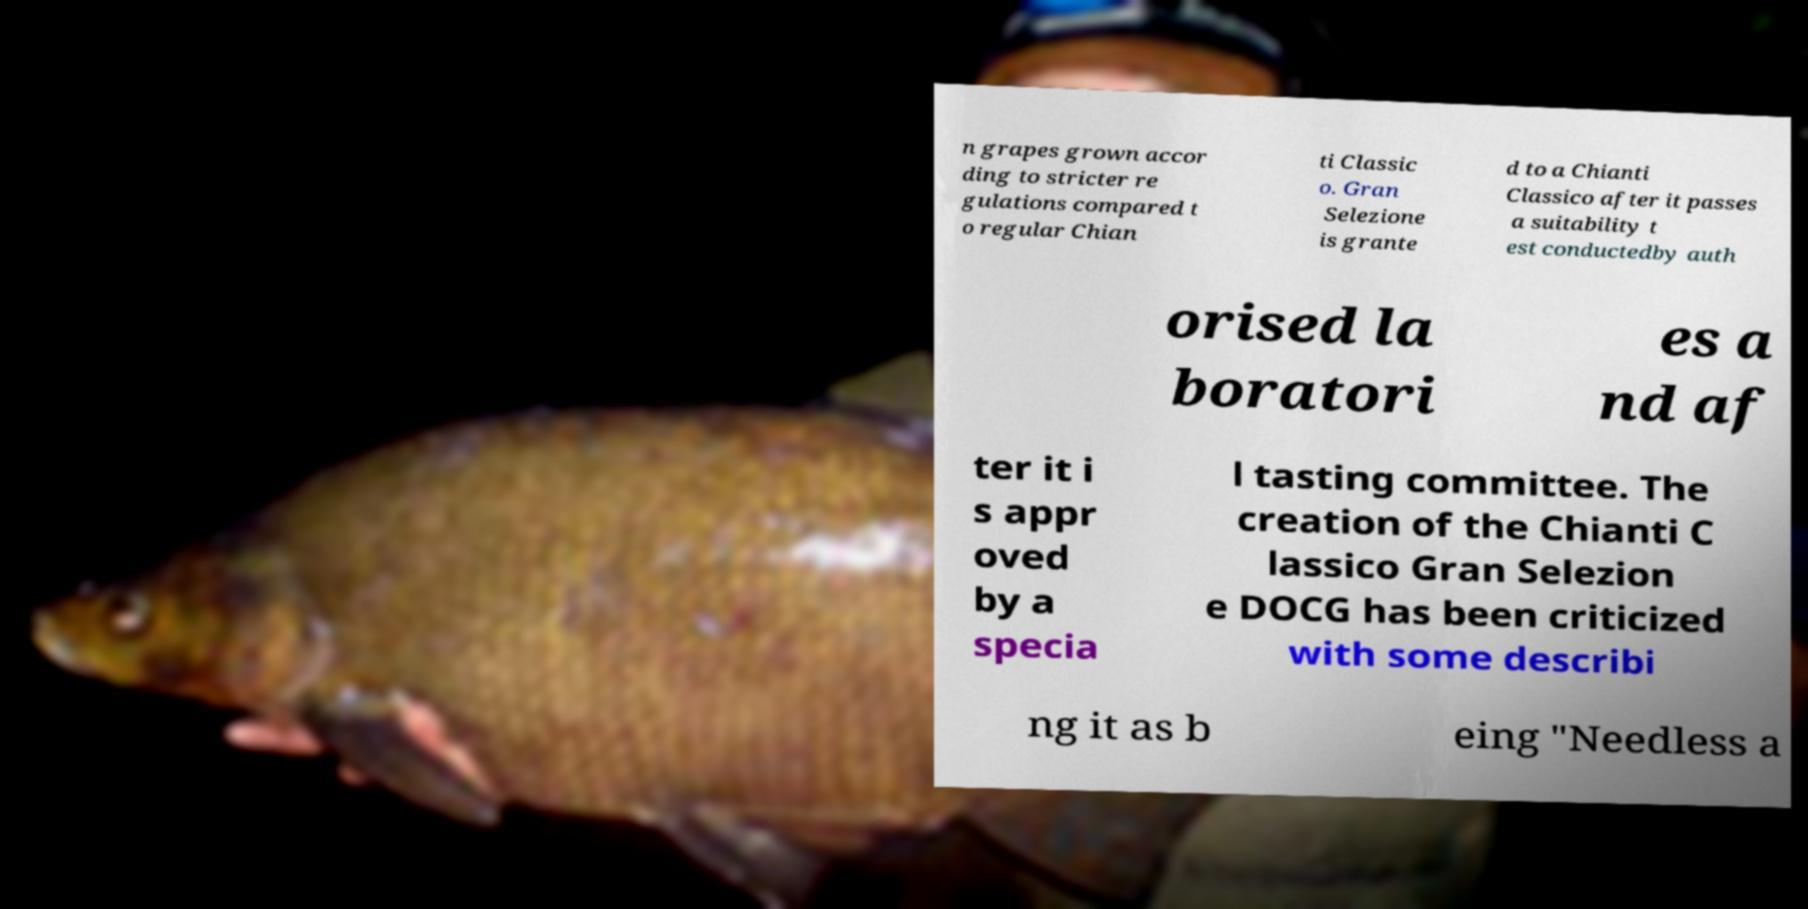Can you accurately transcribe the text from the provided image for me? n grapes grown accor ding to stricter re gulations compared t o regular Chian ti Classic o. Gran Selezione is grante d to a Chianti Classico after it passes a suitability t est conductedby auth orised la boratori es a nd af ter it i s appr oved by a specia l tasting committee. The creation of the Chianti C lassico Gran Selezion e DOCG has been criticized with some describi ng it as b eing "Needless a 